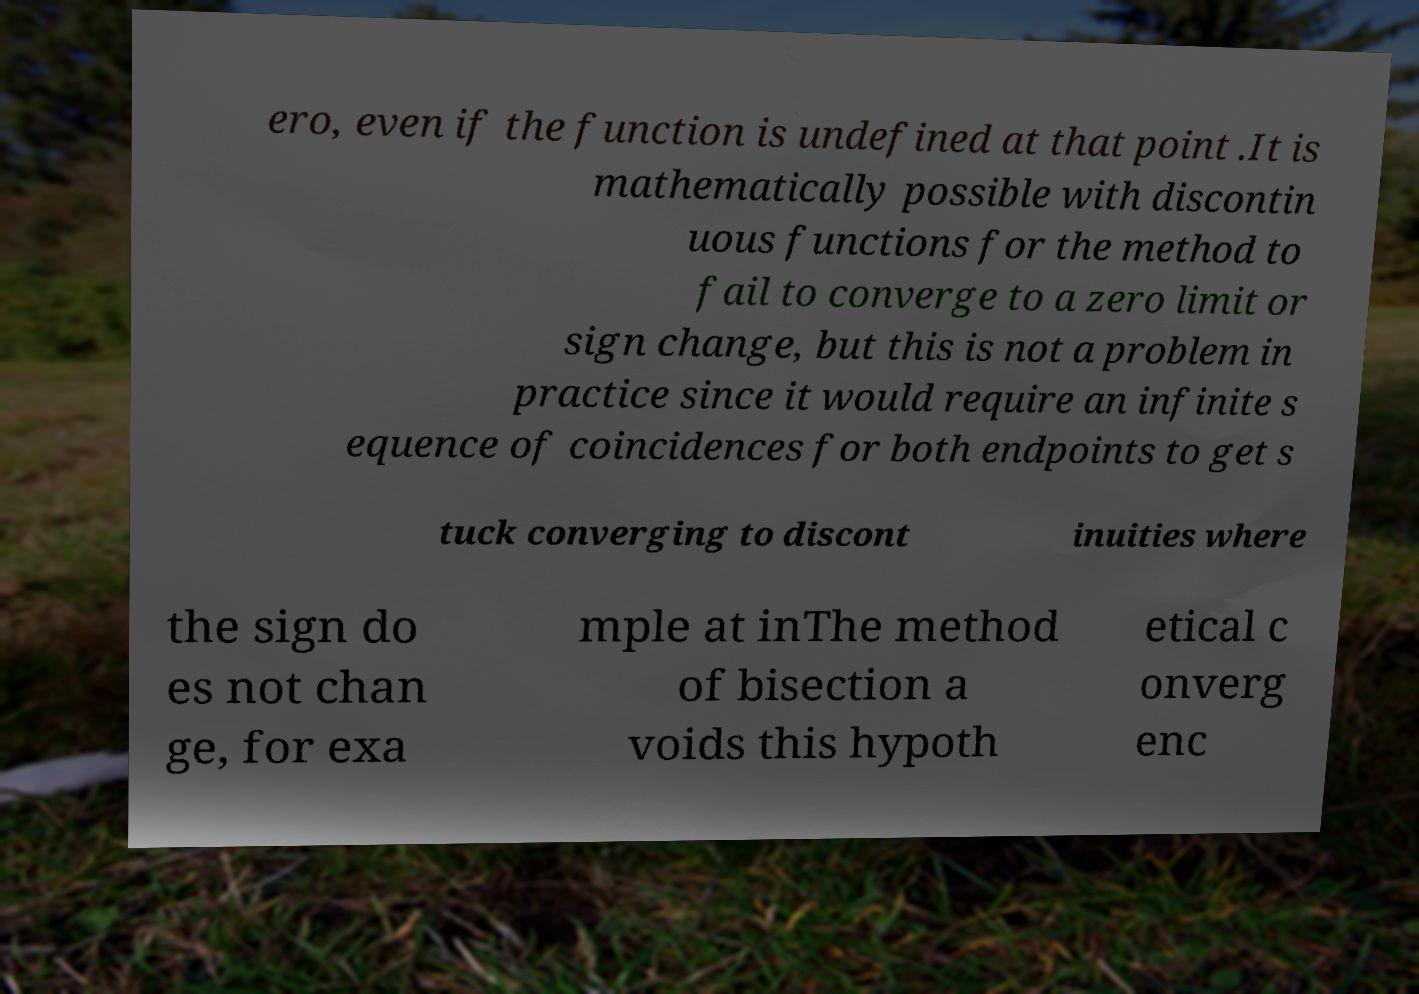Can you accurately transcribe the text from the provided image for me? ero, even if the function is undefined at that point .It is mathematically possible with discontin uous functions for the method to fail to converge to a zero limit or sign change, but this is not a problem in practice since it would require an infinite s equence of coincidences for both endpoints to get s tuck converging to discont inuities where the sign do es not chan ge, for exa mple at inThe method of bisection a voids this hypoth etical c onverg enc 